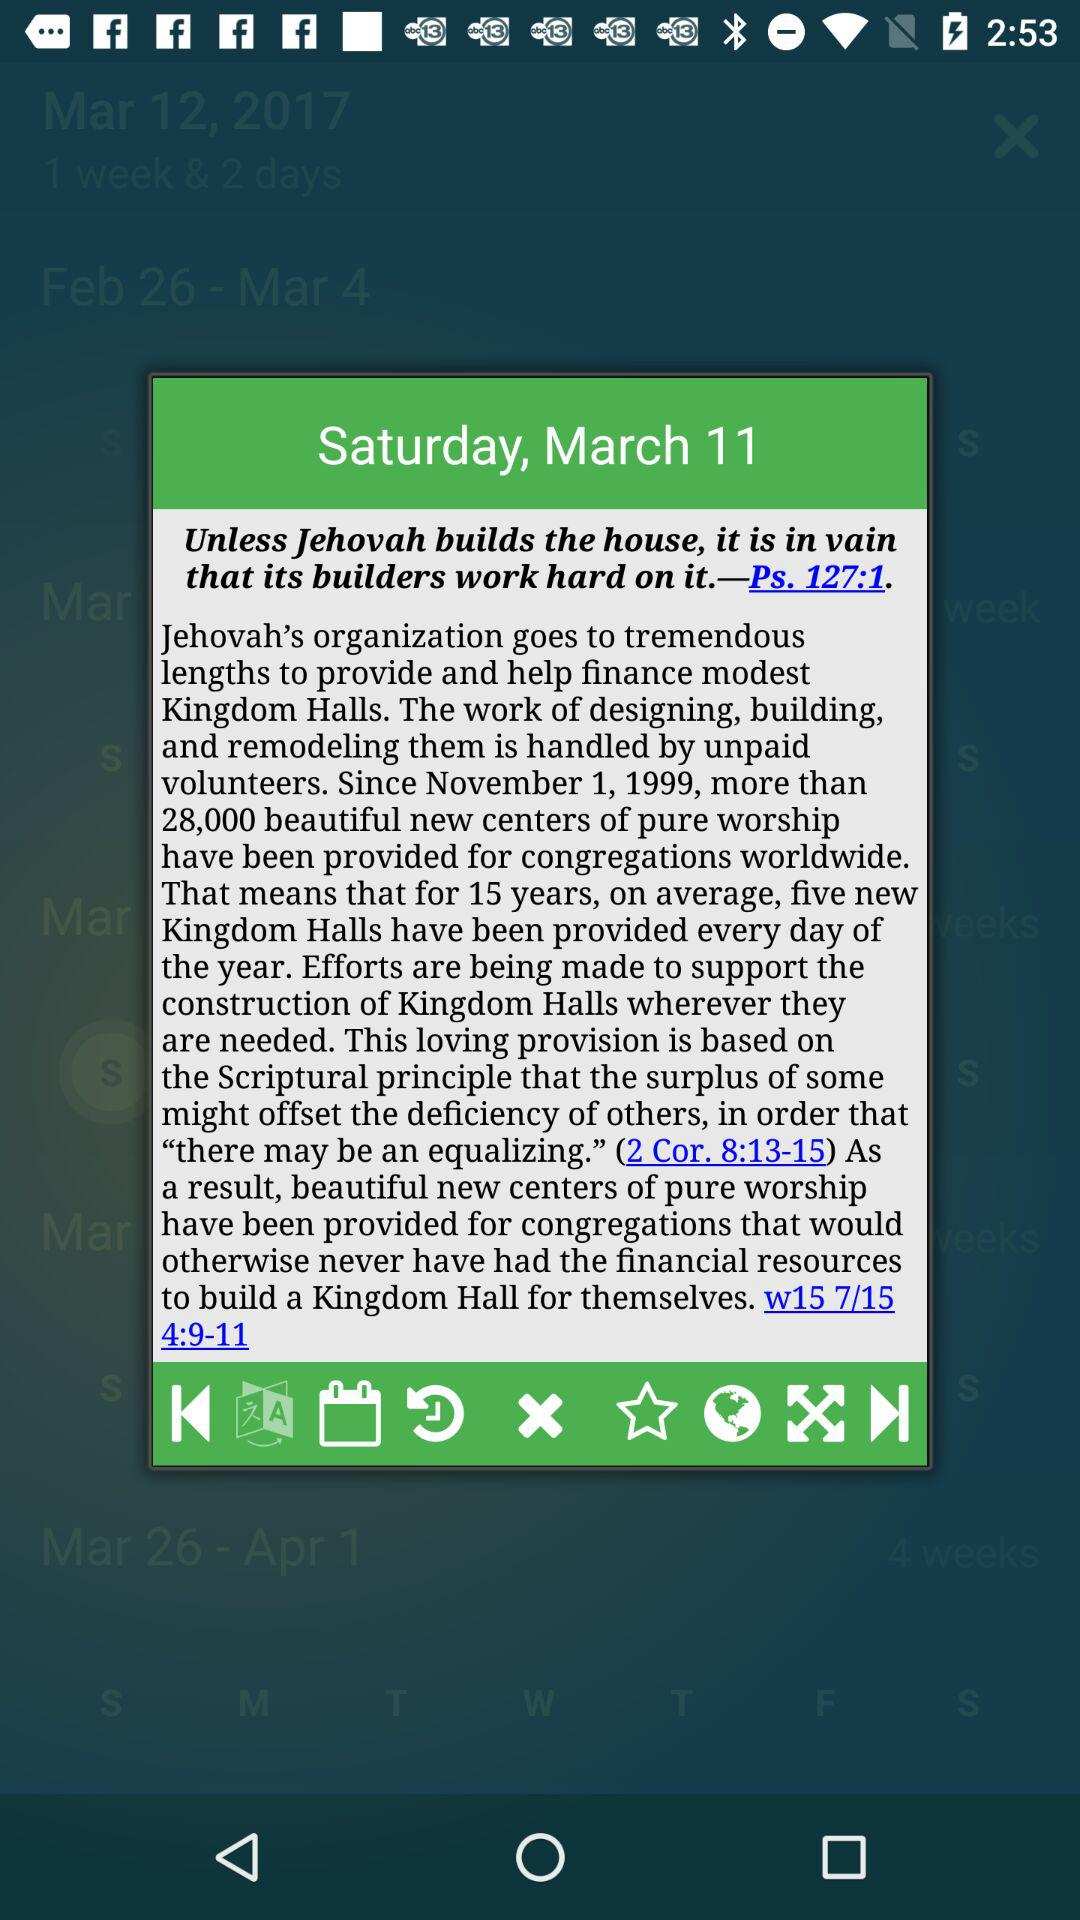What is the day on March 11? The day is "Saturday". 